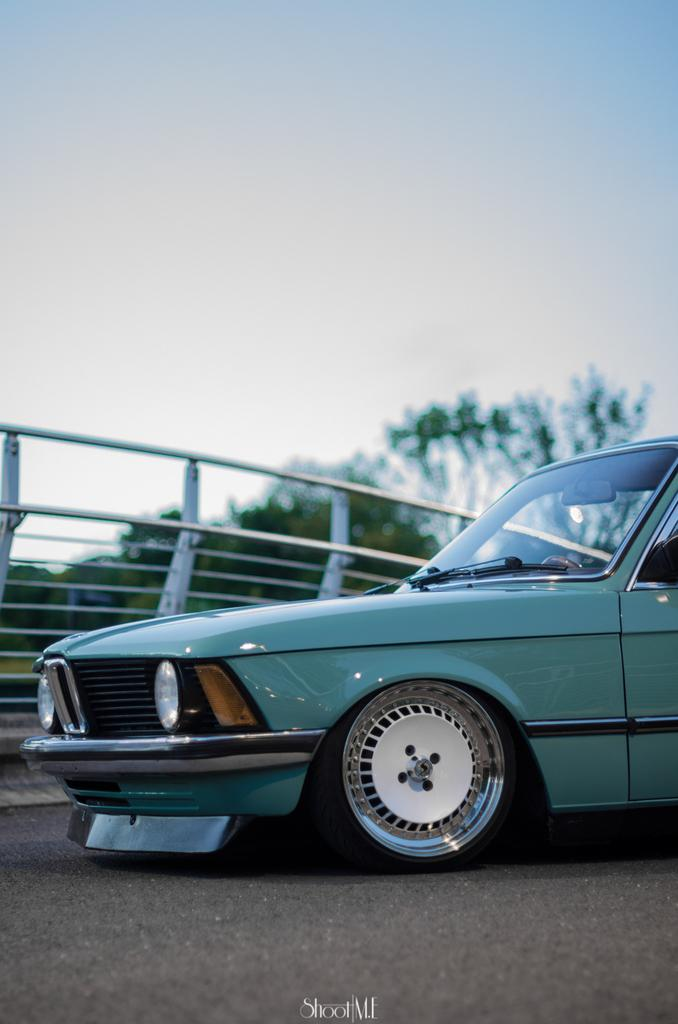What is the main subject in the foreground of the image? There is a car in the foreground of the image. Where is the car located? The car is on the road. What can be seen in the background of the image? There is a railing, trees, and the sky visible in the background of the image. What type of peace symbol can be seen on the car in the image? There is no peace symbol present on the car in the image. Can you tell me how many trains are visible in the image? There are no trains visible in the image; it features a car on the road with a background that includes a railing, trees, and the sky. 